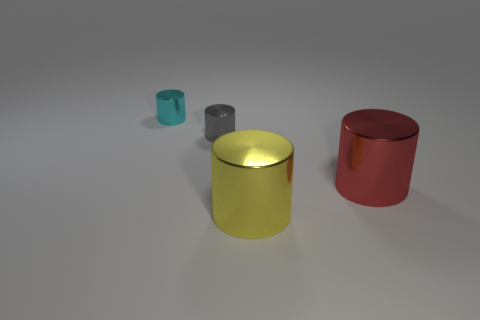Add 1 small blue blocks. How many objects exist? 5 Add 1 tiny red matte things. How many tiny red matte things exist? 1 Subtract 0 green spheres. How many objects are left? 4 Subtract all small red things. Subtract all big red metallic things. How many objects are left? 3 Add 1 small cyan shiny cylinders. How many small cyan shiny cylinders are left? 2 